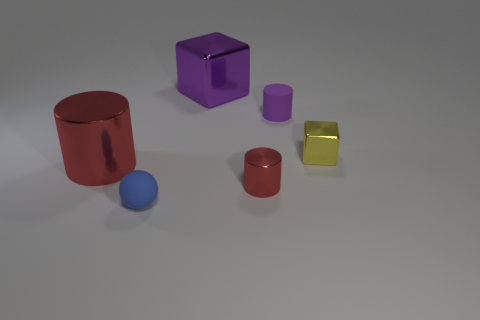Add 2 purple cubes. How many objects exist? 8 Subtract all balls. How many objects are left? 5 Subtract all small red matte cubes. Subtract all purple rubber cylinders. How many objects are left? 5 Add 2 purple matte things. How many purple matte things are left? 3 Add 1 large brown things. How many large brown things exist? 1 Subtract 0 brown cubes. How many objects are left? 6 